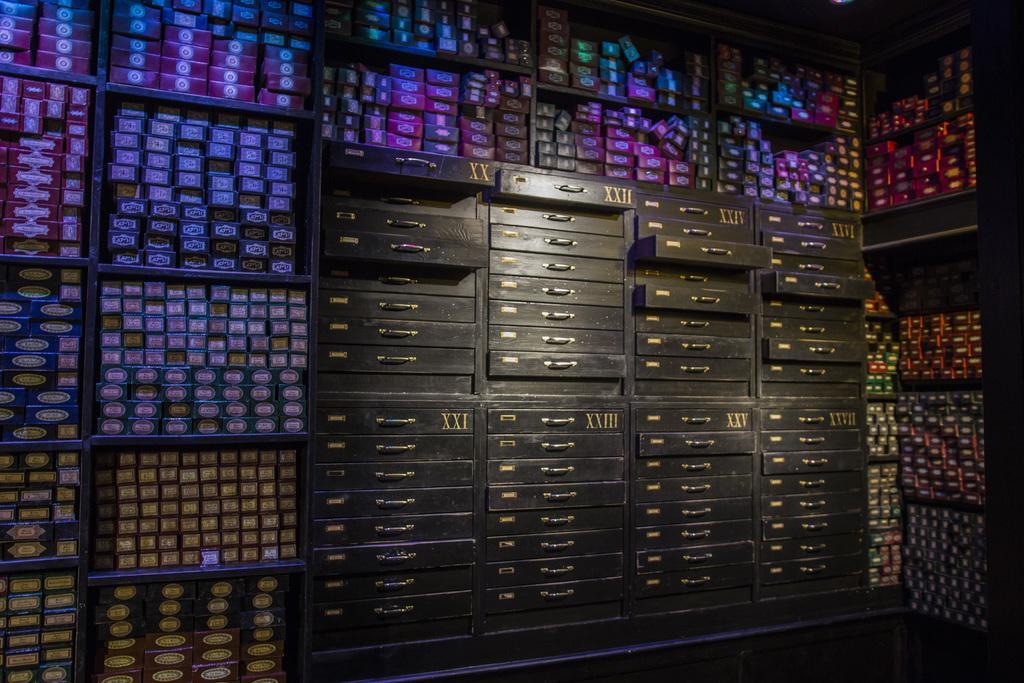Describe this image in one or two sentences. In this picture we can see drawers and boxes on racks. 